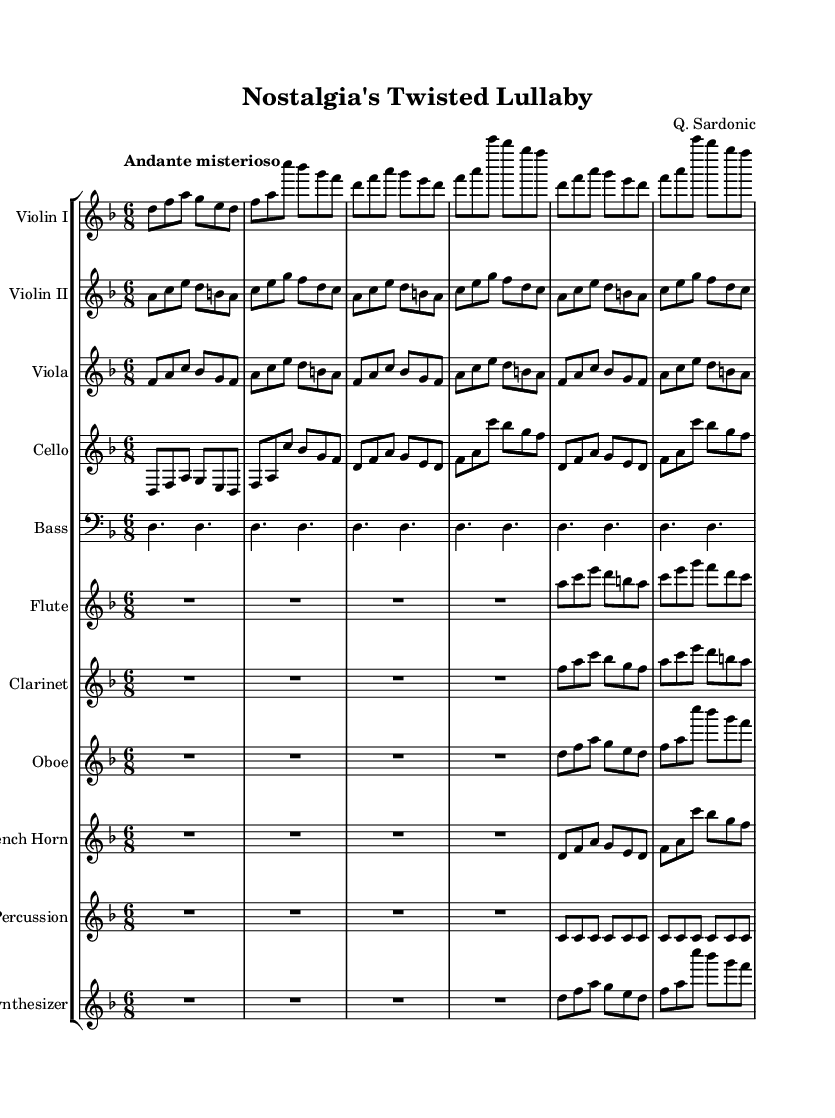What is the key signature of this music? The key signature of the music is D minor, which includes one flat (B flat). This can be determined by looking at the key signature section which shows the flat symbol in the appropriate position.
Answer: D minor What is the time signature of this music? The time signature of the music is 6/8, indicated at the beginning of the score. It shows that there are six eighth note beats per measure, which is characteristic of a compound time signature often used in Romantic music for a flowing and lilting feel.
Answer: 6/8 How many instruments are featured in this composition? The composition features a total of ten instruments. This can be tallied by counting each individual staff in the score, each representing a different instrument part.
Answer: Ten What is the tempo marking given in this piece? The tempo marking for this piece is "Andante misterioso," which suggests a moderately slow tempo with a mysterious quality. This is indicated clearly at the beginning of the score, providing performers with a sense of mood and pacing.
Answer: Andante misterioso Which woodwind instrument is included in this music? The woodwind instruments in this music are the flute, clarinet, oboe, and french horn. They are specifically labeled in their respective staves in the score, showcasing the orchestration of the piece.
Answer: Flute, clarinet, oboe, french horn How many times is the phrase in the violin I part repeated? The phrase in the violin I part is repeated two times. This can be observed in the score where the section is annotated with a repeat symbol, indicating that the performer should play that section again.
Answer: Two 